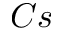Convert formula to latex. <formula><loc_0><loc_0><loc_500><loc_500>C s</formula> 